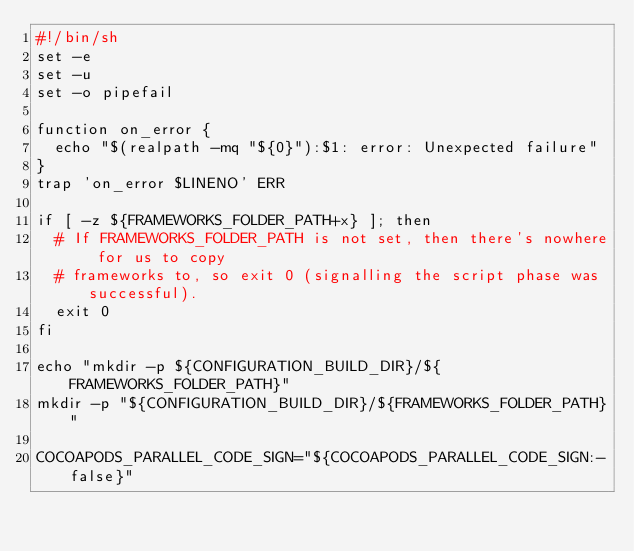<code> <loc_0><loc_0><loc_500><loc_500><_Bash_>#!/bin/sh
set -e
set -u
set -o pipefail

function on_error {
  echo "$(realpath -mq "${0}"):$1: error: Unexpected failure"
}
trap 'on_error $LINENO' ERR

if [ -z ${FRAMEWORKS_FOLDER_PATH+x} ]; then
  # If FRAMEWORKS_FOLDER_PATH is not set, then there's nowhere for us to copy
  # frameworks to, so exit 0 (signalling the script phase was successful).
  exit 0
fi

echo "mkdir -p ${CONFIGURATION_BUILD_DIR}/${FRAMEWORKS_FOLDER_PATH}"
mkdir -p "${CONFIGURATION_BUILD_DIR}/${FRAMEWORKS_FOLDER_PATH}"

COCOAPODS_PARALLEL_CODE_SIGN="${COCOAPODS_PARALLEL_CODE_SIGN:-false}"</code> 